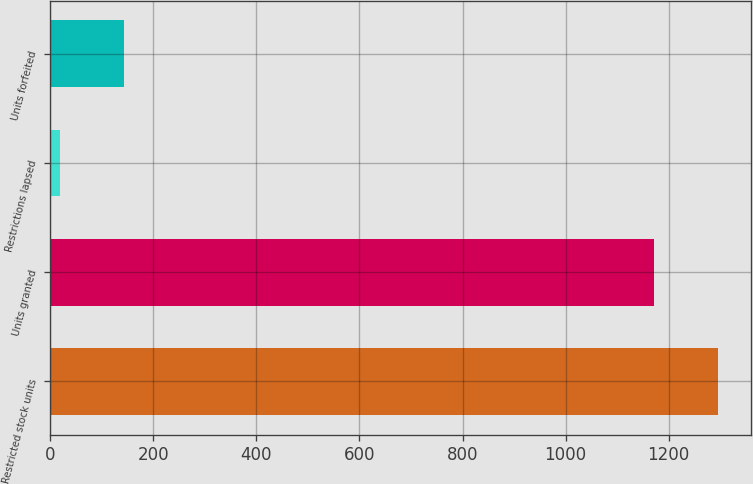Convert chart to OTSL. <chart><loc_0><loc_0><loc_500><loc_500><bar_chart><fcel>Restricted stock units<fcel>Units granted<fcel>Restrictions lapsed<fcel>Units forfeited<nl><fcel>1295.6<fcel>1171<fcel>19<fcel>143.6<nl></chart> 